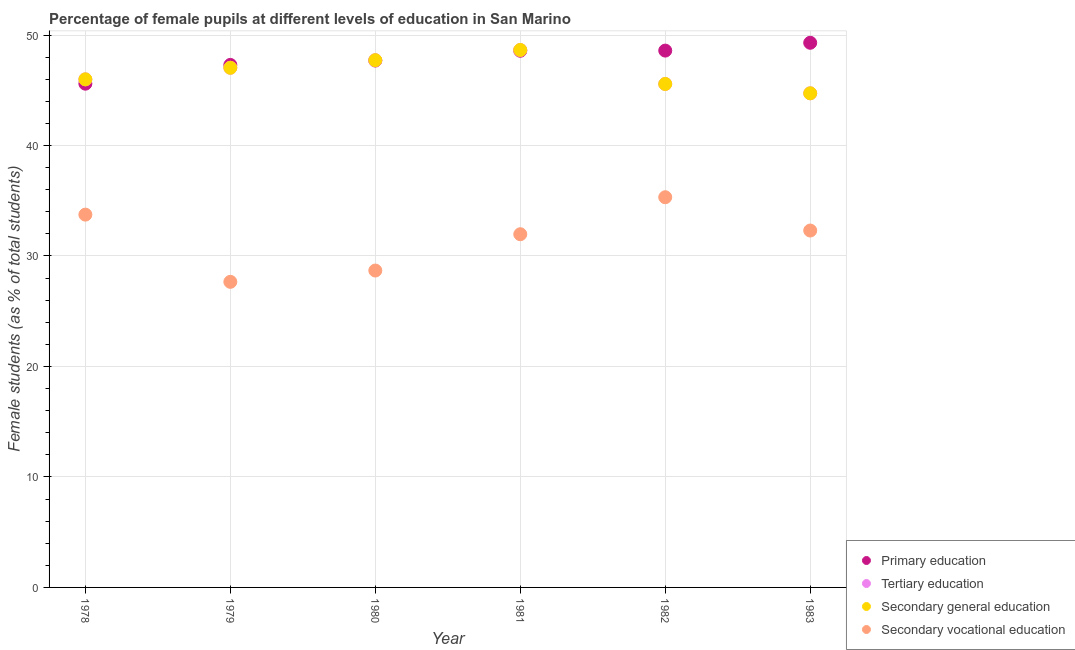How many different coloured dotlines are there?
Ensure brevity in your answer.  4. Is the number of dotlines equal to the number of legend labels?
Keep it short and to the point. Yes. What is the percentage of female students in tertiary education in 1982?
Your answer should be very brief. 45.57. Across all years, what is the maximum percentage of female students in tertiary education?
Provide a succinct answer. 48.65. Across all years, what is the minimum percentage of female students in secondary education?
Ensure brevity in your answer.  44.72. In which year was the percentage of female students in tertiary education maximum?
Keep it short and to the point. 1981. In which year was the percentage of female students in secondary vocational education minimum?
Provide a succinct answer. 1979. What is the total percentage of female students in secondary education in the graph?
Provide a succinct answer. 279.68. What is the difference between the percentage of female students in secondary vocational education in 1978 and that in 1981?
Provide a succinct answer. 1.77. What is the difference between the percentage of female students in secondary vocational education in 1982 and the percentage of female students in primary education in 1979?
Make the answer very short. -11.98. What is the average percentage of female students in tertiary education per year?
Keep it short and to the point. 46.61. In the year 1978, what is the difference between the percentage of female students in primary education and percentage of female students in tertiary education?
Give a very brief answer. -0.39. What is the ratio of the percentage of female students in secondary vocational education in 1979 to that in 1982?
Ensure brevity in your answer.  0.78. Is the percentage of female students in secondary education in 1979 less than that in 1981?
Offer a terse response. Yes. What is the difference between the highest and the second highest percentage of female students in primary education?
Keep it short and to the point. 0.71. What is the difference between the highest and the lowest percentage of female students in secondary vocational education?
Offer a very short reply. 7.66. Is the sum of the percentage of female students in tertiary education in 1978 and 1979 greater than the maximum percentage of female students in primary education across all years?
Provide a succinct answer. Yes. Is the percentage of female students in secondary vocational education strictly greater than the percentage of female students in secondary education over the years?
Your answer should be very brief. No. Is the percentage of female students in secondary education strictly less than the percentage of female students in tertiary education over the years?
Give a very brief answer. No. How many dotlines are there?
Ensure brevity in your answer.  4. How many years are there in the graph?
Offer a terse response. 6. What is the difference between two consecutive major ticks on the Y-axis?
Your response must be concise. 10. Does the graph contain any zero values?
Your answer should be compact. No. How many legend labels are there?
Give a very brief answer. 4. How are the legend labels stacked?
Provide a short and direct response. Vertical. What is the title of the graph?
Your response must be concise. Percentage of female pupils at different levels of education in San Marino. What is the label or title of the Y-axis?
Your answer should be very brief. Female students (as % of total students). What is the Female students (as % of total students) of Primary education in 1978?
Your answer should be compact. 45.59. What is the Female students (as % of total students) in Tertiary education in 1978?
Make the answer very short. 45.99. What is the Female students (as % of total students) in Secondary general education in 1978?
Provide a succinct answer. 45.99. What is the Female students (as % of total students) in Secondary vocational education in 1978?
Keep it short and to the point. 33.74. What is the Female students (as % of total students) in Primary education in 1979?
Ensure brevity in your answer.  47.29. What is the Female students (as % of total students) in Tertiary education in 1979?
Your answer should be compact. 47.03. What is the Female students (as % of total students) of Secondary general education in 1979?
Provide a short and direct response. 47.03. What is the Female students (as % of total students) of Secondary vocational education in 1979?
Ensure brevity in your answer.  27.66. What is the Female students (as % of total students) of Primary education in 1980?
Keep it short and to the point. 47.69. What is the Female students (as % of total students) in Tertiary education in 1980?
Offer a terse response. 47.72. What is the Female students (as % of total students) of Secondary general education in 1980?
Make the answer very short. 47.72. What is the Female students (as % of total students) of Secondary vocational education in 1980?
Your answer should be very brief. 28.68. What is the Female students (as % of total students) of Primary education in 1981?
Offer a very short reply. 48.58. What is the Female students (as % of total students) in Tertiary education in 1981?
Your answer should be very brief. 48.65. What is the Female students (as % of total students) of Secondary general education in 1981?
Offer a very short reply. 48.65. What is the Female students (as % of total students) in Secondary vocational education in 1981?
Offer a very short reply. 31.97. What is the Female students (as % of total students) of Primary education in 1982?
Offer a very short reply. 48.59. What is the Female students (as % of total students) in Tertiary education in 1982?
Your answer should be very brief. 45.57. What is the Female students (as % of total students) in Secondary general education in 1982?
Offer a very short reply. 45.57. What is the Female students (as % of total students) in Secondary vocational education in 1982?
Your response must be concise. 35.32. What is the Female students (as % of total students) in Primary education in 1983?
Provide a short and direct response. 49.3. What is the Female students (as % of total students) of Tertiary education in 1983?
Your response must be concise. 44.72. What is the Female students (as % of total students) of Secondary general education in 1983?
Make the answer very short. 44.72. What is the Female students (as % of total students) in Secondary vocational education in 1983?
Your response must be concise. 32.3. Across all years, what is the maximum Female students (as % of total students) in Primary education?
Offer a terse response. 49.3. Across all years, what is the maximum Female students (as % of total students) in Tertiary education?
Ensure brevity in your answer.  48.65. Across all years, what is the maximum Female students (as % of total students) of Secondary general education?
Keep it short and to the point. 48.65. Across all years, what is the maximum Female students (as % of total students) of Secondary vocational education?
Offer a very short reply. 35.32. Across all years, what is the minimum Female students (as % of total students) in Primary education?
Provide a succinct answer. 45.59. Across all years, what is the minimum Female students (as % of total students) of Tertiary education?
Give a very brief answer. 44.72. Across all years, what is the minimum Female students (as % of total students) of Secondary general education?
Keep it short and to the point. 44.72. Across all years, what is the minimum Female students (as % of total students) in Secondary vocational education?
Your answer should be very brief. 27.66. What is the total Female students (as % of total students) in Primary education in the graph?
Provide a succinct answer. 287.03. What is the total Female students (as % of total students) of Tertiary education in the graph?
Keep it short and to the point. 279.68. What is the total Female students (as % of total students) in Secondary general education in the graph?
Offer a terse response. 279.68. What is the total Female students (as % of total students) in Secondary vocational education in the graph?
Offer a very short reply. 189.67. What is the difference between the Female students (as % of total students) of Primary education in 1978 and that in 1979?
Your answer should be compact. -1.7. What is the difference between the Female students (as % of total students) of Tertiary education in 1978 and that in 1979?
Your answer should be compact. -1.05. What is the difference between the Female students (as % of total students) in Secondary general education in 1978 and that in 1979?
Make the answer very short. -1.05. What is the difference between the Female students (as % of total students) of Secondary vocational education in 1978 and that in 1979?
Your answer should be very brief. 6.08. What is the difference between the Female students (as % of total students) of Primary education in 1978 and that in 1980?
Give a very brief answer. -2.09. What is the difference between the Female students (as % of total students) in Tertiary education in 1978 and that in 1980?
Provide a succinct answer. -1.73. What is the difference between the Female students (as % of total students) of Secondary general education in 1978 and that in 1980?
Offer a very short reply. -1.73. What is the difference between the Female students (as % of total students) in Secondary vocational education in 1978 and that in 1980?
Offer a terse response. 5.06. What is the difference between the Female students (as % of total students) of Primary education in 1978 and that in 1981?
Give a very brief answer. -2.98. What is the difference between the Female students (as % of total students) in Tertiary education in 1978 and that in 1981?
Provide a short and direct response. -2.66. What is the difference between the Female students (as % of total students) of Secondary general education in 1978 and that in 1981?
Offer a very short reply. -2.66. What is the difference between the Female students (as % of total students) in Secondary vocational education in 1978 and that in 1981?
Your answer should be very brief. 1.77. What is the difference between the Female students (as % of total students) of Primary education in 1978 and that in 1982?
Provide a succinct answer. -2.99. What is the difference between the Female students (as % of total students) in Tertiary education in 1978 and that in 1982?
Your response must be concise. 0.42. What is the difference between the Female students (as % of total students) in Secondary general education in 1978 and that in 1982?
Offer a very short reply. 0.42. What is the difference between the Female students (as % of total students) in Secondary vocational education in 1978 and that in 1982?
Ensure brevity in your answer.  -1.57. What is the difference between the Female students (as % of total students) of Primary education in 1978 and that in 1983?
Your answer should be compact. -3.7. What is the difference between the Female students (as % of total students) of Tertiary education in 1978 and that in 1983?
Your answer should be compact. 1.27. What is the difference between the Female students (as % of total students) in Secondary general education in 1978 and that in 1983?
Your answer should be very brief. 1.27. What is the difference between the Female students (as % of total students) in Secondary vocational education in 1978 and that in 1983?
Make the answer very short. 1.44. What is the difference between the Female students (as % of total students) in Primary education in 1979 and that in 1980?
Your response must be concise. -0.4. What is the difference between the Female students (as % of total students) in Tertiary education in 1979 and that in 1980?
Provide a succinct answer. -0.69. What is the difference between the Female students (as % of total students) of Secondary general education in 1979 and that in 1980?
Give a very brief answer. -0.69. What is the difference between the Female students (as % of total students) in Secondary vocational education in 1979 and that in 1980?
Keep it short and to the point. -1.02. What is the difference between the Female students (as % of total students) of Primary education in 1979 and that in 1981?
Make the answer very short. -1.28. What is the difference between the Female students (as % of total students) of Tertiary education in 1979 and that in 1981?
Keep it short and to the point. -1.61. What is the difference between the Female students (as % of total students) in Secondary general education in 1979 and that in 1981?
Provide a succinct answer. -1.61. What is the difference between the Female students (as % of total students) in Secondary vocational education in 1979 and that in 1981?
Make the answer very short. -4.31. What is the difference between the Female students (as % of total students) in Primary education in 1979 and that in 1982?
Ensure brevity in your answer.  -1.3. What is the difference between the Female students (as % of total students) in Tertiary education in 1979 and that in 1982?
Give a very brief answer. 1.47. What is the difference between the Female students (as % of total students) of Secondary general education in 1979 and that in 1982?
Your answer should be very brief. 1.47. What is the difference between the Female students (as % of total students) of Secondary vocational education in 1979 and that in 1982?
Offer a terse response. -7.66. What is the difference between the Female students (as % of total students) of Primary education in 1979 and that in 1983?
Your response must be concise. -2. What is the difference between the Female students (as % of total students) of Tertiary education in 1979 and that in 1983?
Provide a succinct answer. 2.31. What is the difference between the Female students (as % of total students) in Secondary general education in 1979 and that in 1983?
Your answer should be very brief. 2.31. What is the difference between the Female students (as % of total students) in Secondary vocational education in 1979 and that in 1983?
Ensure brevity in your answer.  -4.64. What is the difference between the Female students (as % of total students) in Primary education in 1980 and that in 1981?
Provide a short and direct response. -0.89. What is the difference between the Female students (as % of total students) in Tertiary education in 1980 and that in 1981?
Your answer should be compact. -0.93. What is the difference between the Female students (as % of total students) of Secondary general education in 1980 and that in 1981?
Offer a very short reply. -0.93. What is the difference between the Female students (as % of total students) in Secondary vocational education in 1980 and that in 1981?
Offer a very short reply. -3.29. What is the difference between the Female students (as % of total students) in Primary education in 1980 and that in 1982?
Make the answer very short. -0.9. What is the difference between the Female students (as % of total students) in Tertiary education in 1980 and that in 1982?
Keep it short and to the point. 2.15. What is the difference between the Female students (as % of total students) in Secondary general education in 1980 and that in 1982?
Your answer should be compact. 2.15. What is the difference between the Female students (as % of total students) in Secondary vocational education in 1980 and that in 1982?
Give a very brief answer. -6.63. What is the difference between the Female students (as % of total students) in Primary education in 1980 and that in 1983?
Provide a succinct answer. -1.61. What is the difference between the Female students (as % of total students) in Tertiary education in 1980 and that in 1983?
Give a very brief answer. 3. What is the difference between the Female students (as % of total students) in Secondary general education in 1980 and that in 1983?
Your answer should be very brief. 3. What is the difference between the Female students (as % of total students) of Secondary vocational education in 1980 and that in 1983?
Give a very brief answer. -3.62. What is the difference between the Female students (as % of total students) of Primary education in 1981 and that in 1982?
Ensure brevity in your answer.  -0.01. What is the difference between the Female students (as % of total students) of Tertiary education in 1981 and that in 1982?
Ensure brevity in your answer.  3.08. What is the difference between the Female students (as % of total students) of Secondary general education in 1981 and that in 1982?
Ensure brevity in your answer.  3.08. What is the difference between the Female students (as % of total students) of Secondary vocational education in 1981 and that in 1982?
Your answer should be very brief. -3.35. What is the difference between the Female students (as % of total students) of Primary education in 1981 and that in 1983?
Ensure brevity in your answer.  -0.72. What is the difference between the Female students (as % of total students) of Tertiary education in 1981 and that in 1983?
Give a very brief answer. 3.92. What is the difference between the Female students (as % of total students) in Secondary general education in 1981 and that in 1983?
Provide a short and direct response. 3.92. What is the difference between the Female students (as % of total students) in Secondary vocational education in 1981 and that in 1983?
Your answer should be compact. -0.33. What is the difference between the Female students (as % of total students) of Primary education in 1982 and that in 1983?
Provide a short and direct response. -0.71. What is the difference between the Female students (as % of total students) in Tertiary education in 1982 and that in 1983?
Make the answer very short. 0.85. What is the difference between the Female students (as % of total students) in Secondary general education in 1982 and that in 1983?
Make the answer very short. 0.85. What is the difference between the Female students (as % of total students) of Secondary vocational education in 1982 and that in 1983?
Offer a terse response. 3.02. What is the difference between the Female students (as % of total students) in Primary education in 1978 and the Female students (as % of total students) in Tertiary education in 1979?
Your response must be concise. -1.44. What is the difference between the Female students (as % of total students) in Primary education in 1978 and the Female students (as % of total students) in Secondary general education in 1979?
Provide a short and direct response. -1.44. What is the difference between the Female students (as % of total students) of Primary education in 1978 and the Female students (as % of total students) of Secondary vocational education in 1979?
Give a very brief answer. 17.93. What is the difference between the Female students (as % of total students) in Tertiary education in 1978 and the Female students (as % of total students) in Secondary general education in 1979?
Provide a short and direct response. -1.05. What is the difference between the Female students (as % of total students) of Tertiary education in 1978 and the Female students (as % of total students) of Secondary vocational education in 1979?
Ensure brevity in your answer.  18.33. What is the difference between the Female students (as % of total students) of Secondary general education in 1978 and the Female students (as % of total students) of Secondary vocational education in 1979?
Ensure brevity in your answer.  18.33. What is the difference between the Female students (as % of total students) in Primary education in 1978 and the Female students (as % of total students) in Tertiary education in 1980?
Your response must be concise. -2.13. What is the difference between the Female students (as % of total students) in Primary education in 1978 and the Female students (as % of total students) in Secondary general education in 1980?
Ensure brevity in your answer.  -2.13. What is the difference between the Female students (as % of total students) of Primary education in 1978 and the Female students (as % of total students) of Secondary vocational education in 1980?
Your answer should be very brief. 16.91. What is the difference between the Female students (as % of total students) in Tertiary education in 1978 and the Female students (as % of total students) in Secondary general education in 1980?
Offer a terse response. -1.73. What is the difference between the Female students (as % of total students) in Tertiary education in 1978 and the Female students (as % of total students) in Secondary vocational education in 1980?
Offer a terse response. 17.31. What is the difference between the Female students (as % of total students) of Secondary general education in 1978 and the Female students (as % of total students) of Secondary vocational education in 1980?
Ensure brevity in your answer.  17.31. What is the difference between the Female students (as % of total students) of Primary education in 1978 and the Female students (as % of total students) of Tertiary education in 1981?
Your answer should be very brief. -3.05. What is the difference between the Female students (as % of total students) of Primary education in 1978 and the Female students (as % of total students) of Secondary general education in 1981?
Make the answer very short. -3.05. What is the difference between the Female students (as % of total students) of Primary education in 1978 and the Female students (as % of total students) of Secondary vocational education in 1981?
Your answer should be very brief. 13.63. What is the difference between the Female students (as % of total students) in Tertiary education in 1978 and the Female students (as % of total students) in Secondary general education in 1981?
Your answer should be very brief. -2.66. What is the difference between the Female students (as % of total students) in Tertiary education in 1978 and the Female students (as % of total students) in Secondary vocational education in 1981?
Keep it short and to the point. 14.02. What is the difference between the Female students (as % of total students) of Secondary general education in 1978 and the Female students (as % of total students) of Secondary vocational education in 1981?
Give a very brief answer. 14.02. What is the difference between the Female students (as % of total students) in Primary education in 1978 and the Female students (as % of total students) in Tertiary education in 1982?
Provide a succinct answer. 0.03. What is the difference between the Female students (as % of total students) of Primary education in 1978 and the Female students (as % of total students) of Secondary general education in 1982?
Make the answer very short. 0.03. What is the difference between the Female students (as % of total students) in Primary education in 1978 and the Female students (as % of total students) in Secondary vocational education in 1982?
Make the answer very short. 10.28. What is the difference between the Female students (as % of total students) in Tertiary education in 1978 and the Female students (as % of total students) in Secondary general education in 1982?
Offer a very short reply. 0.42. What is the difference between the Female students (as % of total students) of Tertiary education in 1978 and the Female students (as % of total students) of Secondary vocational education in 1982?
Offer a terse response. 10.67. What is the difference between the Female students (as % of total students) in Secondary general education in 1978 and the Female students (as % of total students) in Secondary vocational education in 1982?
Your response must be concise. 10.67. What is the difference between the Female students (as % of total students) of Primary education in 1978 and the Female students (as % of total students) of Tertiary education in 1983?
Your answer should be very brief. 0.87. What is the difference between the Female students (as % of total students) of Primary education in 1978 and the Female students (as % of total students) of Secondary general education in 1983?
Provide a short and direct response. 0.87. What is the difference between the Female students (as % of total students) of Primary education in 1978 and the Female students (as % of total students) of Secondary vocational education in 1983?
Provide a short and direct response. 13.29. What is the difference between the Female students (as % of total students) in Tertiary education in 1978 and the Female students (as % of total students) in Secondary general education in 1983?
Provide a succinct answer. 1.27. What is the difference between the Female students (as % of total students) of Tertiary education in 1978 and the Female students (as % of total students) of Secondary vocational education in 1983?
Make the answer very short. 13.69. What is the difference between the Female students (as % of total students) of Secondary general education in 1978 and the Female students (as % of total students) of Secondary vocational education in 1983?
Ensure brevity in your answer.  13.69. What is the difference between the Female students (as % of total students) of Primary education in 1979 and the Female students (as % of total students) of Tertiary education in 1980?
Make the answer very short. -0.43. What is the difference between the Female students (as % of total students) of Primary education in 1979 and the Female students (as % of total students) of Secondary general education in 1980?
Offer a very short reply. -0.43. What is the difference between the Female students (as % of total students) of Primary education in 1979 and the Female students (as % of total students) of Secondary vocational education in 1980?
Provide a short and direct response. 18.61. What is the difference between the Female students (as % of total students) in Tertiary education in 1979 and the Female students (as % of total students) in Secondary general education in 1980?
Make the answer very short. -0.69. What is the difference between the Female students (as % of total students) in Tertiary education in 1979 and the Female students (as % of total students) in Secondary vocational education in 1980?
Ensure brevity in your answer.  18.35. What is the difference between the Female students (as % of total students) in Secondary general education in 1979 and the Female students (as % of total students) in Secondary vocational education in 1980?
Offer a very short reply. 18.35. What is the difference between the Female students (as % of total students) in Primary education in 1979 and the Female students (as % of total students) in Tertiary education in 1981?
Your answer should be compact. -1.35. What is the difference between the Female students (as % of total students) of Primary education in 1979 and the Female students (as % of total students) of Secondary general education in 1981?
Your answer should be compact. -1.35. What is the difference between the Female students (as % of total students) in Primary education in 1979 and the Female students (as % of total students) in Secondary vocational education in 1981?
Offer a terse response. 15.32. What is the difference between the Female students (as % of total students) in Tertiary education in 1979 and the Female students (as % of total students) in Secondary general education in 1981?
Make the answer very short. -1.61. What is the difference between the Female students (as % of total students) in Tertiary education in 1979 and the Female students (as % of total students) in Secondary vocational education in 1981?
Provide a succinct answer. 15.07. What is the difference between the Female students (as % of total students) of Secondary general education in 1979 and the Female students (as % of total students) of Secondary vocational education in 1981?
Your response must be concise. 15.07. What is the difference between the Female students (as % of total students) of Primary education in 1979 and the Female students (as % of total students) of Tertiary education in 1982?
Keep it short and to the point. 1.72. What is the difference between the Female students (as % of total students) of Primary education in 1979 and the Female students (as % of total students) of Secondary general education in 1982?
Provide a succinct answer. 1.72. What is the difference between the Female students (as % of total students) in Primary education in 1979 and the Female students (as % of total students) in Secondary vocational education in 1982?
Your answer should be compact. 11.98. What is the difference between the Female students (as % of total students) of Tertiary education in 1979 and the Female students (as % of total students) of Secondary general education in 1982?
Ensure brevity in your answer.  1.47. What is the difference between the Female students (as % of total students) in Tertiary education in 1979 and the Female students (as % of total students) in Secondary vocational education in 1982?
Provide a short and direct response. 11.72. What is the difference between the Female students (as % of total students) of Secondary general education in 1979 and the Female students (as % of total students) of Secondary vocational education in 1982?
Provide a succinct answer. 11.72. What is the difference between the Female students (as % of total students) of Primary education in 1979 and the Female students (as % of total students) of Tertiary education in 1983?
Offer a terse response. 2.57. What is the difference between the Female students (as % of total students) in Primary education in 1979 and the Female students (as % of total students) in Secondary general education in 1983?
Your answer should be very brief. 2.57. What is the difference between the Female students (as % of total students) in Primary education in 1979 and the Female students (as % of total students) in Secondary vocational education in 1983?
Give a very brief answer. 14.99. What is the difference between the Female students (as % of total students) of Tertiary education in 1979 and the Female students (as % of total students) of Secondary general education in 1983?
Offer a terse response. 2.31. What is the difference between the Female students (as % of total students) of Tertiary education in 1979 and the Female students (as % of total students) of Secondary vocational education in 1983?
Keep it short and to the point. 14.73. What is the difference between the Female students (as % of total students) of Secondary general education in 1979 and the Female students (as % of total students) of Secondary vocational education in 1983?
Make the answer very short. 14.73. What is the difference between the Female students (as % of total students) of Primary education in 1980 and the Female students (as % of total students) of Tertiary education in 1981?
Your answer should be very brief. -0.96. What is the difference between the Female students (as % of total students) in Primary education in 1980 and the Female students (as % of total students) in Secondary general education in 1981?
Your response must be concise. -0.96. What is the difference between the Female students (as % of total students) in Primary education in 1980 and the Female students (as % of total students) in Secondary vocational education in 1981?
Ensure brevity in your answer.  15.72. What is the difference between the Female students (as % of total students) in Tertiary education in 1980 and the Female students (as % of total students) in Secondary general education in 1981?
Ensure brevity in your answer.  -0.93. What is the difference between the Female students (as % of total students) of Tertiary education in 1980 and the Female students (as % of total students) of Secondary vocational education in 1981?
Provide a succinct answer. 15.75. What is the difference between the Female students (as % of total students) of Secondary general education in 1980 and the Female students (as % of total students) of Secondary vocational education in 1981?
Offer a very short reply. 15.75. What is the difference between the Female students (as % of total students) of Primary education in 1980 and the Female students (as % of total students) of Tertiary education in 1982?
Your response must be concise. 2.12. What is the difference between the Female students (as % of total students) of Primary education in 1980 and the Female students (as % of total students) of Secondary general education in 1982?
Your response must be concise. 2.12. What is the difference between the Female students (as % of total students) of Primary education in 1980 and the Female students (as % of total students) of Secondary vocational education in 1982?
Provide a succinct answer. 12.37. What is the difference between the Female students (as % of total students) in Tertiary education in 1980 and the Female students (as % of total students) in Secondary general education in 1982?
Make the answer very short. 2.15. What is the difference between the Female students (as % of total students) of Tertiary education in 1980 and the Female students (as % of total students) of Secondary vocational education in 1982?
Keep it short and to the point. 12.4. What is the difference between the Female students (as % of total students) of Secondary general education in 1980 and the Female students (as % of total students) of Secondary vocational education in 1982?
Make the answer very short. 12.4. What is the difference between the Female students (as % of total students) of Primary education in 1980 and the Female students (as % of total students) of Tertiary education in 1983?
Offer a terse response. 2.96. What is the difference between the Female students (as % of total students) of Primary education in 1980 and the Female students (as % of total students) of Secondary general education in 1983?
Your answer should be very brief. 2.96. What is the difference between the Female students (as % of total students) in Primary education in 1980 and the Female students (as % of total students) in Secondary vocational education in 1983?
Provide a short and direct response. 15.39. What is the difference between the Female students (as % of total students) of Tertiary education in 1980 and the Female students (as % of total students) of Secondary general education in 1983?
Offer a very short reply. 3. What is the difference between the Female students (as % of total students) in Tertiary education in 1980 and the Female students (as % of total students) in Secondary vocational education in 1983?
Provide a succinct answer. 15.42. What is the difference between the Female students (as % of total students) of Secondary general education in 1980 and the Female students (as % of total students) of Secondary vocational education in 1983?
Your answer should be very brief. 15.42. What is the difference between the Female students (as % of total students) in Primary education in 1981 and the Female students (as % of total students) in Tertiary education in 1982?
Your response must be concise. 3.01. What is the difference between the Female students (as % of total students) of Primary education in 1981 and the Female students (as % of total students) of Secondary general education in 1982?
Provide a succinct answer. 3.01. What is the difference between the Female students (as % of total students) of Primary education in 1981 and the Female students (as % of total students) of Secondary vocational education in 1982?
Your answer should be compact. 13.26. What is the difference between the Female students (as % of total students) of Tertiary education in 1981 and the Female students (as % of total students) of Secondary general education in 1982?
Provide a short and direct response. 3.08. What is the difference between the Female students (as % of total students) of Tertiary education in 1981 and the Female students (as % of total students) of Secondary vocational education in 1982?
Provide a short and direct response. 13.33. What is the difference between the Female students (as % of total students) in Secondary general education in 1981 and the Female students (as % of total students) in Secondary vocational education in 1982?
Ensure brevity in your answer.  13.33. What is the difference between the Female students (as % of total students) of Primary education in 1981 and the Female students (as % of total students) of Tertiary education in 1983?
Provide a short and direct response. 3.85. What is the difference between the Female students (as % of total students) of Primary education in 1981 and the Female students (as % of total students) of Secondary general education in 1983?
Your answer should be very brief. 3.85. What is the difference between the Female students (as % of total students) of Primary education in 1981 and the Female students (as % of total students) of Secondary vocational education in 1983?
Provide a short and direct response. 16.27. What is the difference between the Female students (as % of total students) of Tertiary education in 1981 and the Female students (as % of total students) of Secondary general education in 1983?
Make the answer very short. 3.92. What is the difference between the Female students (as % of total students) of Tertiary education in 1981 and the Female students (as % of total students) of Secondary vocational education in 1983?
Provide a short and direct response. 16.34. What is the difference between the Female students (as % of total students) of Secondary general education in 1981 and the Female students (as % of total students) of Secondary vocational education in 1983?
Keep it short and to the point. 16.34. What is the difference between the Female students (as % of total students) of Primary education in 1982 and the Female students (as % of total students) of Tertiary education in 1983?
Provide a short and direct response. 3.87. What is the difference between the Female students (as % of total students) in Primary education in 1982 and the Female students (as % of total students) in Secondary general education in 1983?
Make the answer very short. 3.87. What is the difference between the Female students (as % of total students) of Primary education in 1982 and the Female students (as % of total students) of Secondary vocational education in 1983?
Provide a short and direct response. 16.29. What is the difference between the Female students (as % of total students) of Tertiary education in 1982 and the Female students (as % of total students) of Secondary general education in 1983?
Offer a terse response. 0.85. What is the difference between the Female students (as % of total students) of Tertiary education in 1982 and the Female students (as % of total students) of Secondary vocational education in 1983?
Provide a succinct answer. 13.27. What is the difference between the Female students (as % of total students) in Secondary general education in 1982 and the Female students (as % of total students) in Secondary vocational education in 1983?
Offer a very short reply. 13.27. What is the average Female students (as % of total students) of Primary education per year?
Ensure brevity in your answer.  47.84. What is the average Female students (as % of total students) in Tertiary education per year?
Ensure brevity in your answer.  46.61. What is the average Female students (as % of total students) in Secondary general education per year?
Offer a very short reply. 46.61. What is the average Female students (as % of total students) in Secondary vocational education per year?
Offer a terse response. 31.61. In the year 1978, what is the difference between the Female students (as % of total students) of Primary education and Female students (as % of total students) of Tertiary education?
Your answer should be compact. -0.39. In the year 1978, what is the difference between the Female students (as % of total students) in Primary education and Female students (as % of total students) in Secondary general education?
Keep it short and to the point. -0.39. In the year 1978, what is the difference between the Female students (as % of total students) in Primary education and Female students (as % of total students) in Secondary vocational education?
Keep it short and to the point. 11.85. In the year 1978, what is the difference between the Female students (as % of total students) in Tertiary education and Female students (as % of total students) in Secondary vocational education?
Your response must be concise. 12.25. In the year 1978, what is the difference between the Female students (as % of total students) in Secondary general education and Female students (as % of total students) in Secondary vocational education?
Your response must be concise. 12.25. In the year 1979, what is the difference between the Female students (as % of total students) in Primary education and Female students (as % of total students) in Tertiary education?
Offer a terse response. 0.26. In the year 1979, what is the difference between the Female students (as % of total students) of Primary education and Female students (as % of total students) of Secondary general education?
Provide a succinct answer. 0.26. In the year 1979, what is the difference between the Female students (as % of total students) in Primary education and Female students (as % of total students) in Secondary vocational education?
Your response must be concise. 19.63. In the year 1979, what is the difference between the Female students (as % of total students) of Tertiary education and Female students (as % of total students) of Secondary general education?
Ensure brevity in your answer.  0. In the year 1979, what is the difference between the Female students (as % of total students) in Tertiary education and Female students (as % of total students) in Secondary vocational education?
Your answer should be very brief. 19.37. In the year 1979, what is the difference between the Female students (as % of total students) in Secondary general education and Female students (as % of total students) in Secondary vocational education?
Make the answer very short. 19.37. In the year 1980, what is the difference between the Female students (as % of total students) of Primary education and Female students (as % of total students) of Tertiary education?
Offer a terse response. -0.03. In the year 1980, what is the difference between the Female students (as % of total students) in Primary education and Female students (as % of total students) in Secondary general education?
Offer a terse response. -0.03. In the year 1980, what is the difference between the Female students (as % of total students) in Primary education and Female students (as % of total students) in Secondary vocational education?
Give a very brief answer. 19.01. In the year 1980, what is the difference between the Female students (as % of total students) of Tertiary education and Female students (as % of total students) of Secondary vocational education?
Give a very brief answer. 19.04. In the year 1980, what is the difference between the Female students (as % of total students) of Secondary general education and Female students (as % of total students) of Secondary vocational education?
Offer a very short reply. 19.04. In the year 1981, what is the difference between the Female students (as % of total students) in Primary education and Female students (as % of total students) in Tertiary education?
Give a very brief answer. -0.07. In the year 1981, what is the difference between the Female students (as % of total students) of Primary education and Female students (as % of total students) of Secondary general education?
Your response must be concise. -0.07. In the year 1981, what is the difference between the Female students (as % of total students) of Primary education and Female students (as % of total students) of Secondary vocational education?
Give a very brief answer. 16.61. In the year 1981, what is the difference between the Female students (as % of total students) in Tertiary education and Female students (as % of total students) in Secondary general education?
Make the answer very short. 0. In the year 1981, what is the difference between the Female students (as % of total students) of Tertiary education and Female students (as % of total students) of Secondary vocational education?
Offer a very short reply. 16.68. In the year 1981, what is the difference between the Female students (as % of total students) in Secondary general education and Female students (as % of total students) in Secondary vocational education?
Your answer should be compact. 16.68. In the year 1982, what is the difference between the Female students (as % of total students) of Primary education and Female students (as % of total students) of Tertiary education?
Offer a very short reply. 3.02. In the year 1982, what is the difference between the Female students (as % of total students) in Primary education and Female students (as % of total students) in Secondary general education?
Your answer should be very brief. 3.02. In the year 1982, what is the difference between the Female students (as % of total students) in Primary education and Female students (as % of total students) in Secondary vocational education?
Give a very brief answer. 13.27. In the year 1982, what is the difference between the Female students (as % of total students) in Tertiary education and Female students (as % of total students) in Secondary general education?
Provide a succinct answer. 0. In the year 1982, what is the difference between the Female students (as % of total students) in Tertiary education and Female students (as % of total students) in Secondary vocational education?
Offer a very short reply. 10.25. In the year 1982, what is the difference between the Female students (as % of total students) in Secondary general education and Female students (as % of total students) in Secondary vocational education?
Offer a terse response. 10.25. In the year 1983, what is the difference between the Female students (as % of total students) in Primary education and Female students (as % of total students) in Tertiary education?
Make the answer very short. 4.57. In the year 1983, what is the difference between the Female students (as % of total students) in Primary education and Female students (as % of total students) in Secondary general education?
Your answer should be very brief. 4.57. In the year 1983, what is the difference between the Female students (as % of total students) in Primary education and Female students (as % of total students) in Secondary vocational education?
Make the answer very short. 17. In the year 1983, what is the difference between the Female students (as % of total students) of Tertiary education and Female students (as % of total students) of Secondary general education?
Make the answer very short. 0. In the year 1983, what is the difference between the Female students (as % of total students) in Tertiary education and Female students (as % of total students) in Secondary vocational education?
Your answer should be very brief. 12.42. In the year 1983, what is the difference between the Female students (as % of total students) in Secondary general education and Female students (as % of total students) in Secondary vocational education?
Your answer should be compact. 12.42. What is the ratio of the Female students (as % of total students) of Primary education in 1978 to that in 1979?
Your response must be concise. 0.96. What is the ratio of the Female students (as % of total students) in Tertiary education in 1978 to that in 1979?
Provide a short and direct response. 0.98. What is the ratio of the Female students (as % of total students) of Secondary general education in 1978 to that in 1979?
Your answer should be very brief. 0.98. What is the ratio of the Female students (as % of total students) in Secondary vocational education in 1978 to that in 1979?
Provide a short and direct response. 1.22. What is the ratio of the Female students (as % of total students) in Primary education in 1978 to that in 1980?
Make the answer very short. 0.96. What is the ratio of the Female students (as % of total students) of Tertiary education in 1978 to that in 1980?
Offer a very short reply. 0.96. What is the ratio of the Female students (as % of total students) in Secondary general education in 1978 to that in 1980?
Give a very brief answer. 0.96. What is the ratio of the Female students (as % of total students) in Secondary vocational education in 1978 to that in 1980?
Your answer should be compact. 1.18. What is the ratio of the Female students (as % of total students) of Primary education in 1978 to that in 1981?
Keep it short and to the point. 0.94. What is the ratio of the Female students (as % of total students) of Tertiary education in 1978 to that in 1981?
Your answer should be compact. 0.95. What is the ratio of the Female students (as % of total students) of Secondary general education in 1978 to that in 1981?
Give a very brief answer. 0.95. What is the ratio of the Female students (as % of total students) of Secondary vocational education in 1978 to that in 1981?
Ensure brevity in your answer.  1.06. What is the ratio of the Female students (as % of total students) in Primary education in 1978 to that in 1982?
Offer a terse response. 0.94. What is the ratio of the Female students (as % of total students) in Tertiary education in 1978 to that in 1982?
Give a very brief answer. 1.01. What is the ratio of the Female students (as % of total students) in Secondary general education in 1978 to that in 1982?
Ensure brevity in your answer.  1.01. What is the ratio of the Female students (as % of total students) in Secondary vocational education in 1978 to that in 1982?
Keep it short and to the point. 0.96. What is the ratio of the Female students (as % of total students) in Primary education in 1978 to that in 1983?
Your response must be concise. 0.92. What is the ratio of the Female students (as % of total students) in Tertiary education in 1978 to that in 1983?
Ensure brevity in your answer.  1.03. What is the ratio of the Female students (as % of total students) of Secondary general education in 1978 to that in 1983?
Keep it short and to the point. 1.03. What is the ratio of the Female students (as % of total students) of Secondary vocational education in 1978 to that in 1983?
Your answer should be compact. 1.04. What is the ratio of the Female students (as % of total students) of Primary education in 1979 to that in 1980?
Offer a terse response. 0.99. What is the ratio of the Female students (as % of total students) of Tertiary education in 1979 to that in 1980?
Keep it short and to the point. 0.99. What is the ratio of the Female students (as % of total students) of Secondary general education in 1979 to that in 1980?
Provide a succinct answer. 0.99. What is the ratio of the Female students (as % of total students) of Primary education in 1979 to that in 1981?
Offer a very short reply. 0.97. What is the ratio of the Female students (as % of total students) of Tertiary education in 1979 to that in 1981?
Your response must be concise. 0.97. What is the ratio of the Female students (as % of total students) of Secondary general education in 1979 to that in 1981?
Make the answer very short. 0.97. What is the ratio of the Female students (as % of total students) of Secondary vocational education in 1979 to that in 1981?
Offer a terse response. 0.87. What is the ratio of the Female students (as % of total students) of Primary education in 1979 to that in 1982?
Keep it short and to the point. 0.97. What is the ratio of the Female students (as % of total students) in Tertiary education in 1979 to that in 1982?
Give a very brief answer. 1.03. What is the ratio of the Female students (as % of total students) of Secondary general education in 1979 to that in 1982?
Your answer should be very brief. 1.03. What is the ratio of the Female students (as % of total students) of Secondary vocational education in 1979 to that in 1982?
Give a very brief answer. 0.78. What is the ratio of the Female students (as % of total students) in Primary education in 1979 to that in 1983?
Give a very brief answer. 0.96. What is the ratio of the Female students (as % of total students) of Tertiary education in 1979 to that in 1983?
Ensure brevity in your answer.  1.05. What is the ratio of the Female students (as % of total students) of Secondary general education in 1979 to that in 1983?
Offer a very short reply. 1.05. What is the ratio of the Female students (as % of total students) of Secondary vocational education in 1979 to that in 1983?
Make the answer very short. 0.86. What is the ratio of the Female students (as % of total students) of Primary education in 1980 to that in 1981?
Provide a succinct answer. 0.98. What is the ratio of the Female students (as % of total students) in Secondary vocational education in 1980 to that in 1981?
Keep it short and to the point. 0.9. What is the ratio of the Female students (as % of total students) in Primary education in 1980 to that in 1982?
Ensure brevity in your answer.  0.98. What is the ratio of the Female students (as % of total students) of Tertiary education in 1980 to that in 1982?
Provide a short and direct response. 1.05. What is the ratio of the Female students (as % of total students) in Secondary general education in 1980 to that in 1982?
Make the answer very short. 1.05. What is the ratio of the Female students (as % of total students) of Secondary vocational education in 1980 to that in 1982?
Offer a terse response. 0.81. What is the ratio of the Female students (as % of total students) in Primary education in 1980 to that in 1983?
Your answer should be very brief. 0.97. What is the ratio of the Female students (as % of total students) of Tertiary education in 1980 to that in 1983?
Your response must be concise. 1.07. What is the ratio of the Female students (as % of total students) in Secondary general education in 1980 to that in 1983?
Provide a short and direct response. 1.07. What is the ratio of the Female students (as % of total students) in Secondary vocational education in 1980 to that in 1983?
Offer a terse response. 0.89. What is the ratio of the Female students (as % of total students) of Tertiary education in 1981 to that in 1982?
Provide a succinct answer. 1.07. What is the ratio of the Female students (as % of total students) in Secondary general education in 1981 to that in 1982?
Your answer should be very brief. 1.07. What is the ratio of the Female students (as % of total students) of Secondary vocational education in 1981 to that in 1982?
Your response must be concise. 0.91. What is the ratio of the Female students (as % of total students) in Primary education in 1981 to that in 1983?
Your answer should be very brief. 0.99. What is the ratio of the Female students (as % of total students) in Tertiary education in 1981 to that in 1983?
Your answer should be very brief. 1.09. What is the ratio of the Female students (as % of total students) in Secondary general education in 1981 to that in 1983?
Keep it short and to the point. 1.09. What is the ratio of the Female students (as % of total students) of Secondary vocational education in 1981 to that in 1983?
Give a very brief answer. 0.99. What is the ratio of the Female students (as % of total students) in Primary education in 1982 to that in 1983?
Ensure brevity in your answer.  0.99. What is the ratio of the Female students (as % of total students) in Tertiary education in 1982 to that in 1983?
Provide a succinct answer. 1.02. What is the ratio of the Female students (as % of total students) of Secondary general education in 1982 to that in 1983?
Provide a short and direct response. 1.02. What is the ratio of the Female students (as % of total students) of Secondary vocational education in 1982 to that in 1983?
Provide a short and direct response. 1.09. What is the difference between the highest and the second highest Female students (as % of total students) in Primary education?
Give a very brief answer. 0.71. What is the difference between the highest and the second highest Female students (as % of total students) in Tertiary education?
Your answer should be compact. 0.93. What is the difference between the highest and the second highest Female students (as % of total students) in Secondary general education?
Give a very brief answer. 0.93. What is the difference between the highest and the second highest Female students (as % of total students) in Secondary vocational education?
Keep it short and to the point. 1.57. What is the difference between the highest and the lowest Female students (as % of total students) in Primary education?
Offer a terse response. 3.7. What is the difference between the highest and the lowest Female students (as % of total students) in Tertiary education?
Make the answer very short. 3.92. What is the difference between the highest and the lowest Female students (as % of total students) in Secondary general education?
Your answer should be compact. 3.92. What is the difference between the highest and the lowest Female students (as % of total students) in Secondary vocational education?
Provide a succinct answer. 7.66. 